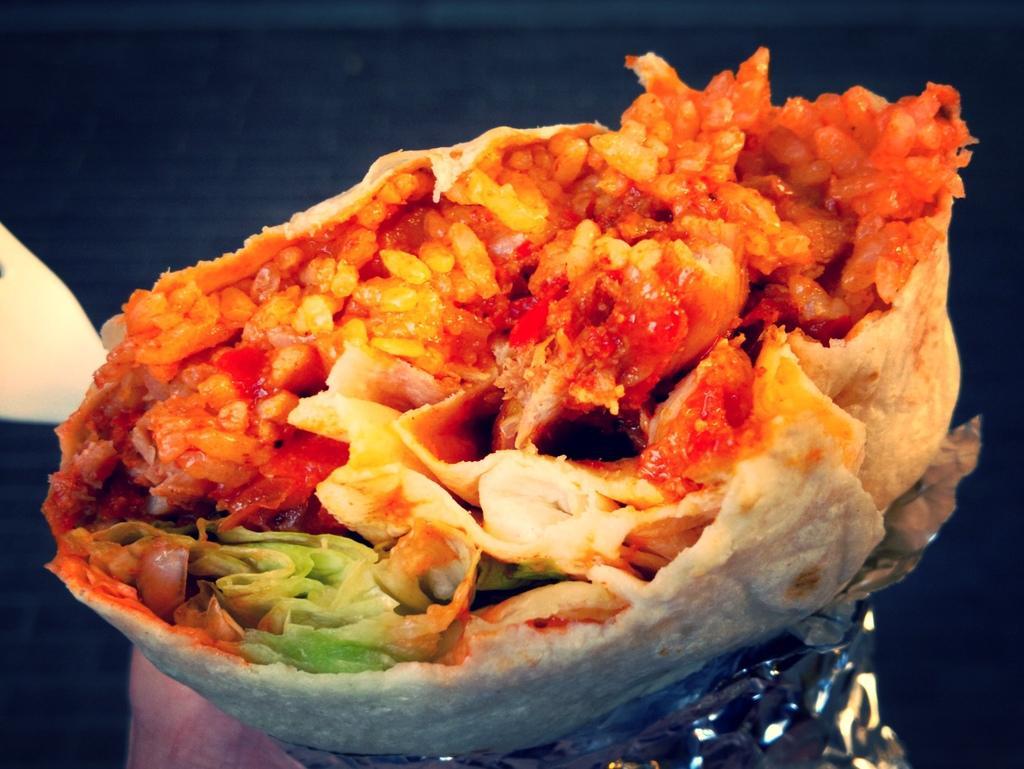In one or two sentences, can you explain what this image depicts? In this image I can see food in the center and on the bottom side of this image I can see an aluminium foil. 